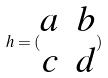Convert formula to latex. <formula><loc_0><loc_0><loc_500><loc_500>h = ( \begin{matrix} a & b \\ c & d \end{matrix} )</formula> 